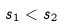<formula> <loc_0><loc_0><loc_500><loc_500>s _ { 1 } < s _ { 2 }</formula> 